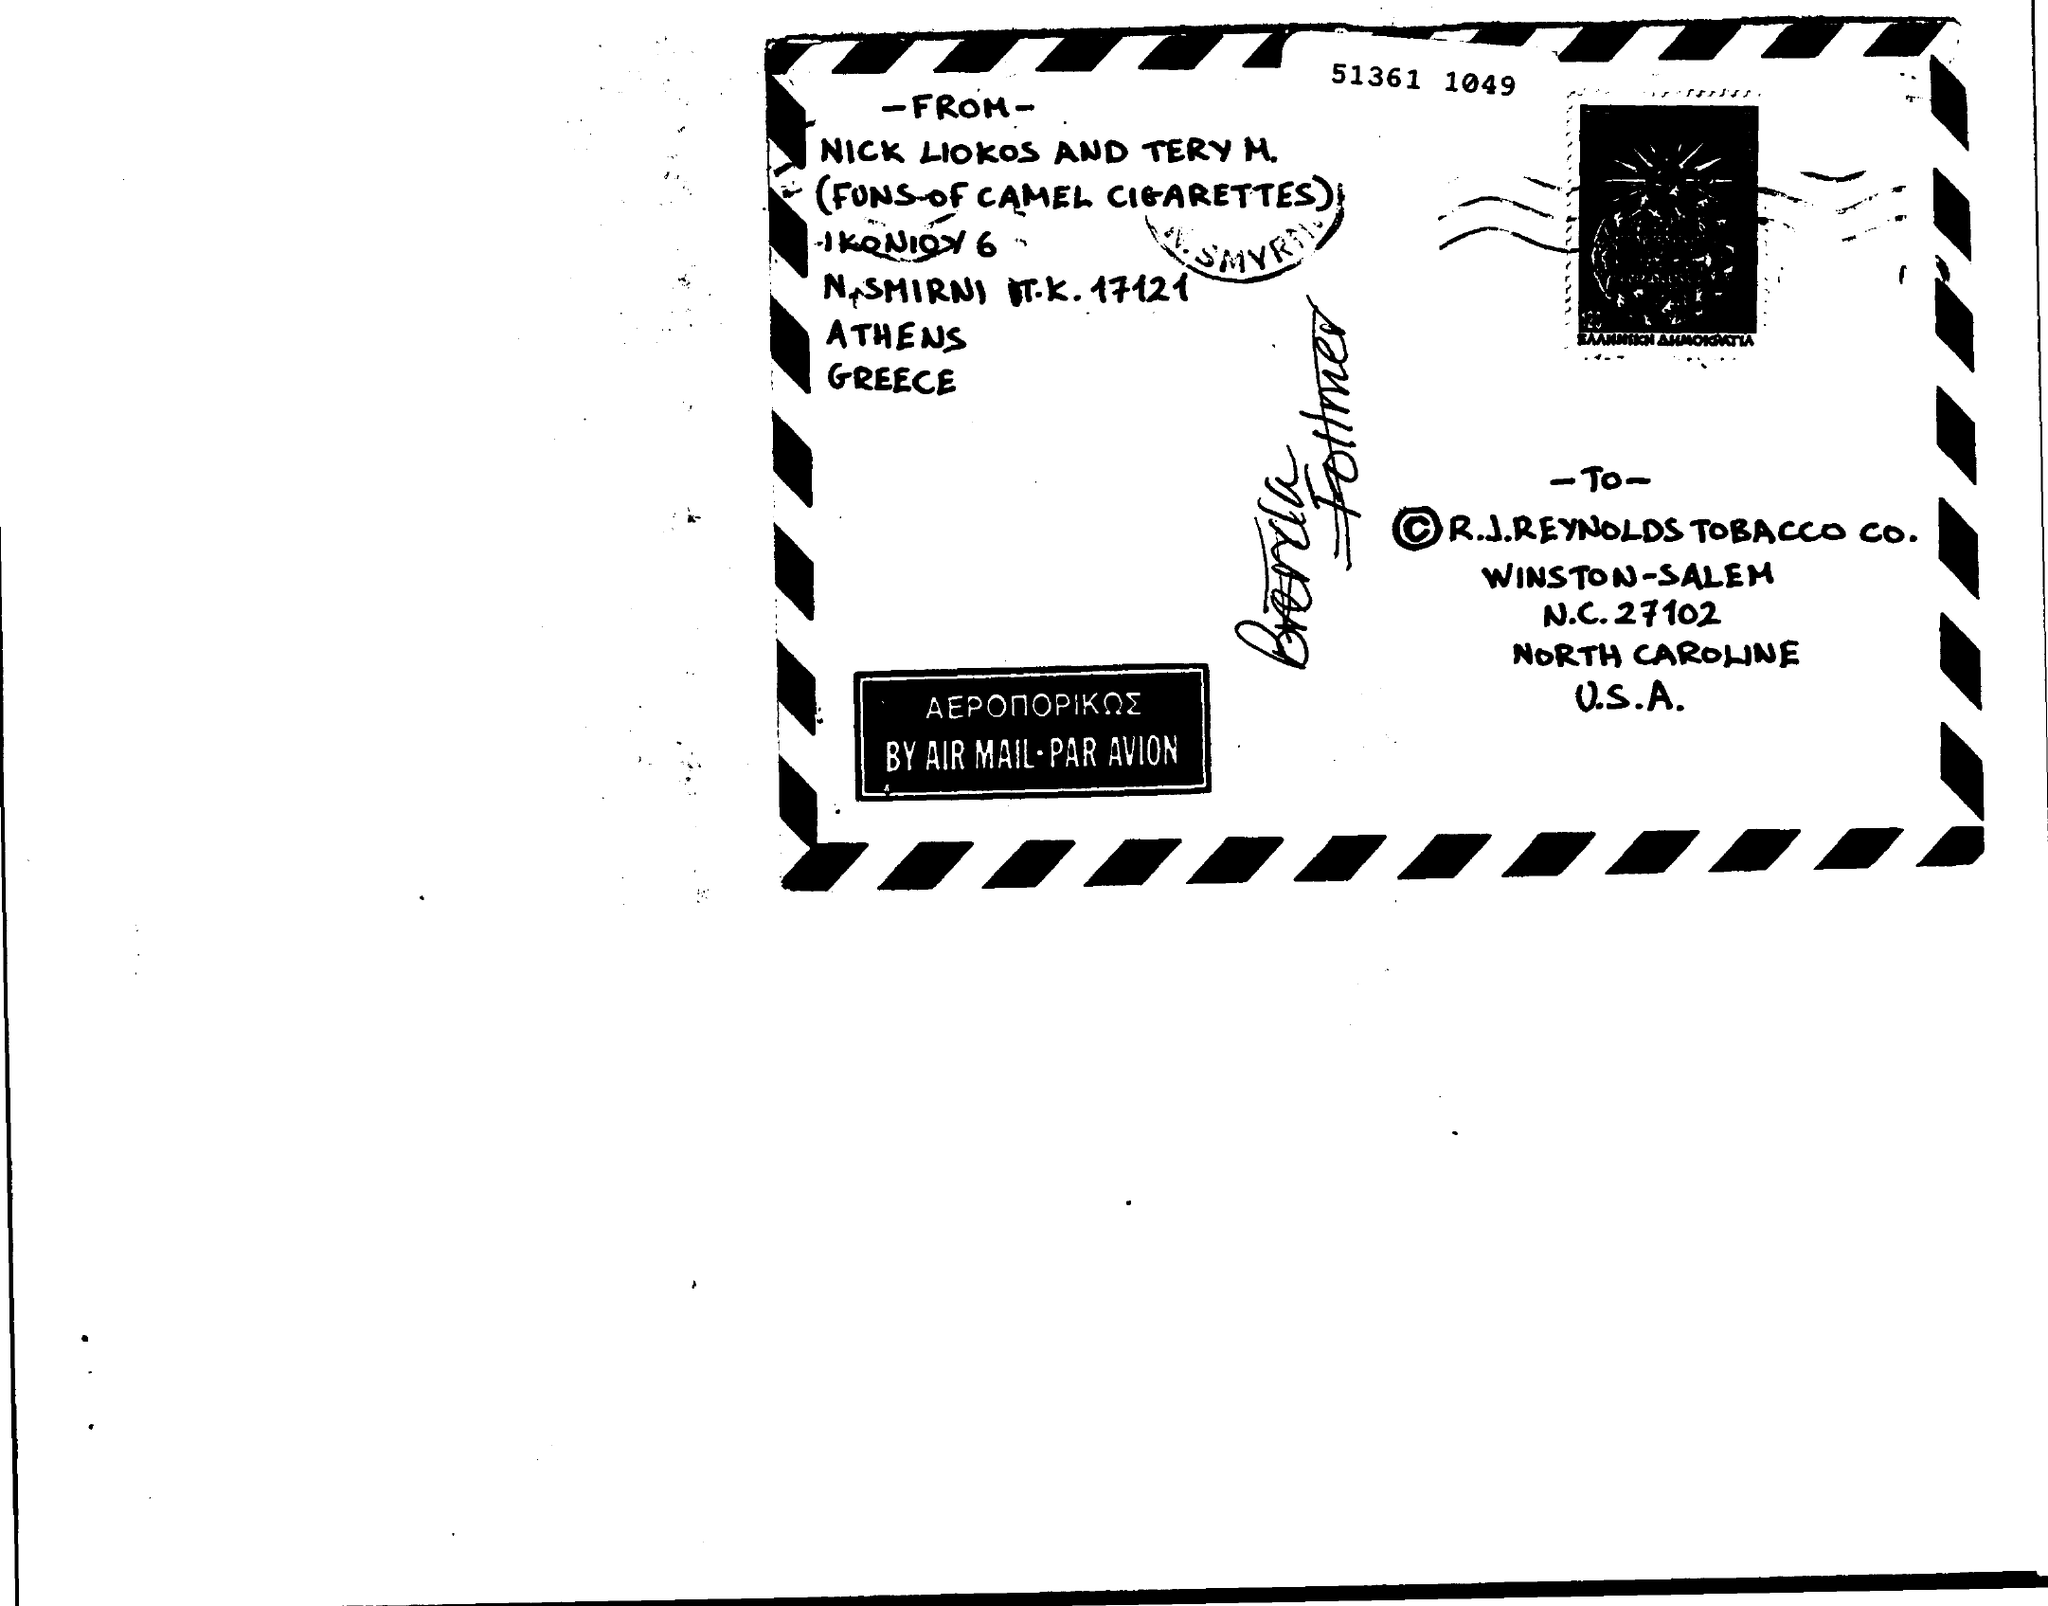Who is the Memorandum from ?
Provide a succinct answer. NICK LIOKOS AND TERY M. Who is the Memorandum addressed to ?
Ensure brevity in your answer.  R.J.REYNOLDS TOBACCO CO. 